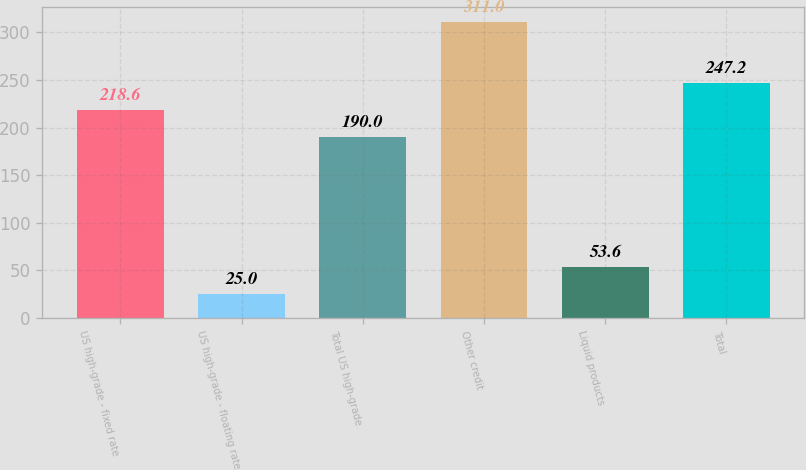Convert chart. <chart><loc_0><loc_0><loc_500><loc_500><bar_chart><fcel>US high-grade - fixed rate<fcel>US high-grade - floating rate<fcel>Total US high-grade<fcel>Other credit<fcel>Liquid products<fcel>Total<nl><fcel>218.6<fcel>25<fcel>190<fcel>311<fcel>53.6<fcel>247.2<nl></chart> 